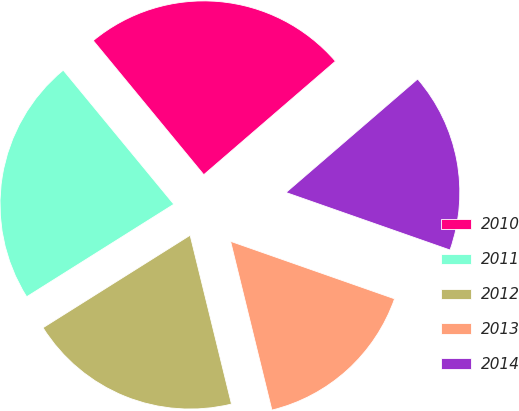Convert chart to OTSL. <chart><loc_0><loc_0><loc_500><loc_500><pie_chart><fcel>2010<fcel>2011<fcel>2012<fcel>2013<fcel>2014<nl><fcel>24.65%<fcel>22.96%<fcel>19.89%<fcel>15.81%<fcel>16.69%<nl></chart> 